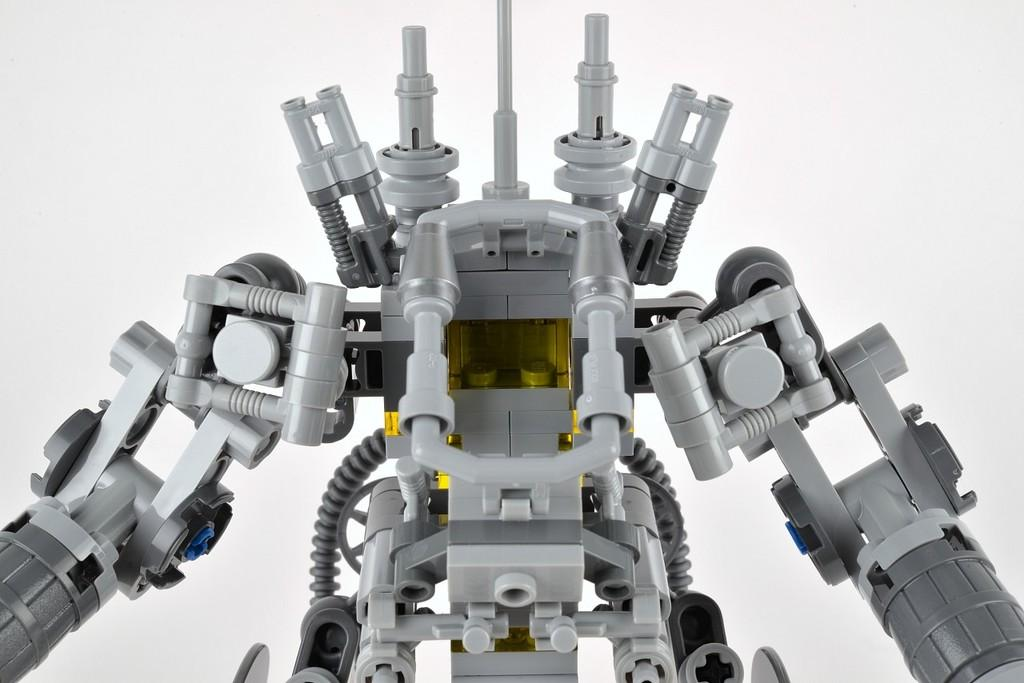What is the main subject of the image? The main subject of the image is a toy robot. What color is the background of the image? The background of the image is white. What type of parcel is the toy robot holding in the image? The toy robot is not holding any parcel in the image. Is the writer of the image visible in the image? There is no reference to a writer in the image, and no person is visible. 